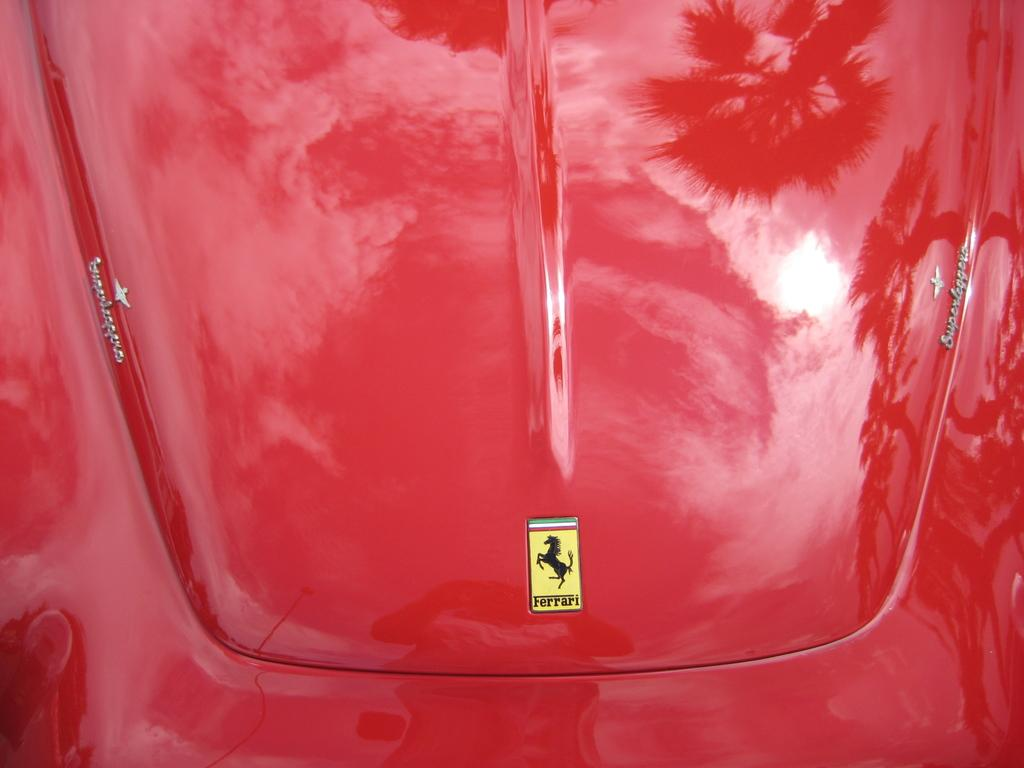What is the color of the vehicle in the picture? The vehicle in the picture is red. Can you describe any specific features of the vehicle? Yes, there is a logo visible on the vehicle. What language is spoken by the ornament on the vehicle in the image? There is no ornament present in the image, and therefore no language can be attributed to it. 